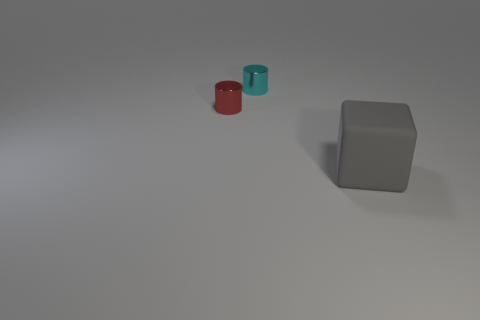Add 1 tiny cyan shiny spheres. How many objects exist? 4 Subtract all cylinders. How many objects are left? 1 Subtract 1 red cylinders. How many objects are left? 2 Subtract 2 cylinders. How many cylinders are left? 0 Subtract all cyan cylinders. Subtract all cyan balls. How many cylinders are left? 1 Subtract all green cubes. How many cyan cylinders are left? 1 Subtract all small yellow shiny cubes. Subtract all red things. How many objects are left? 2 Add 1 small cyan cylinders. How many small cyan cylinders are left? 2 Add 3 cyan things. How many cyan things exist? 4 